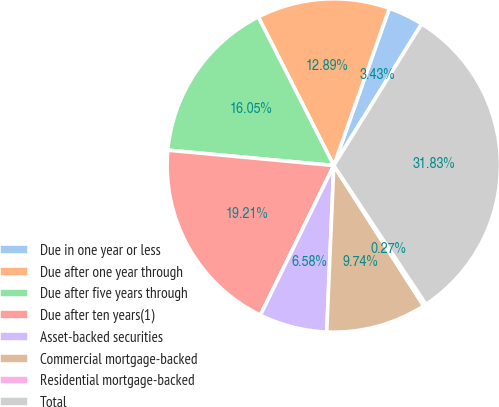<chart> <loc_0><loc_0><loc_500><loc_500><pie_chart><fcel>Due in one year or less<fcel>Due after one year through<fcel>Due after five years through<fcel>Due after ten years(1)<fcel>Asset-backed securities<fcel>Commercial mortgage-backed<fcel>Residential mortgage-backed<fcel>Total<nl><fcel>3.43%<fcel>12.89%<fcel>16.05%<fcel>19.21%<fcel>6.58%<fcel>9.74%<fcel>0.27%<fcel>31.83%<nl></chart> 